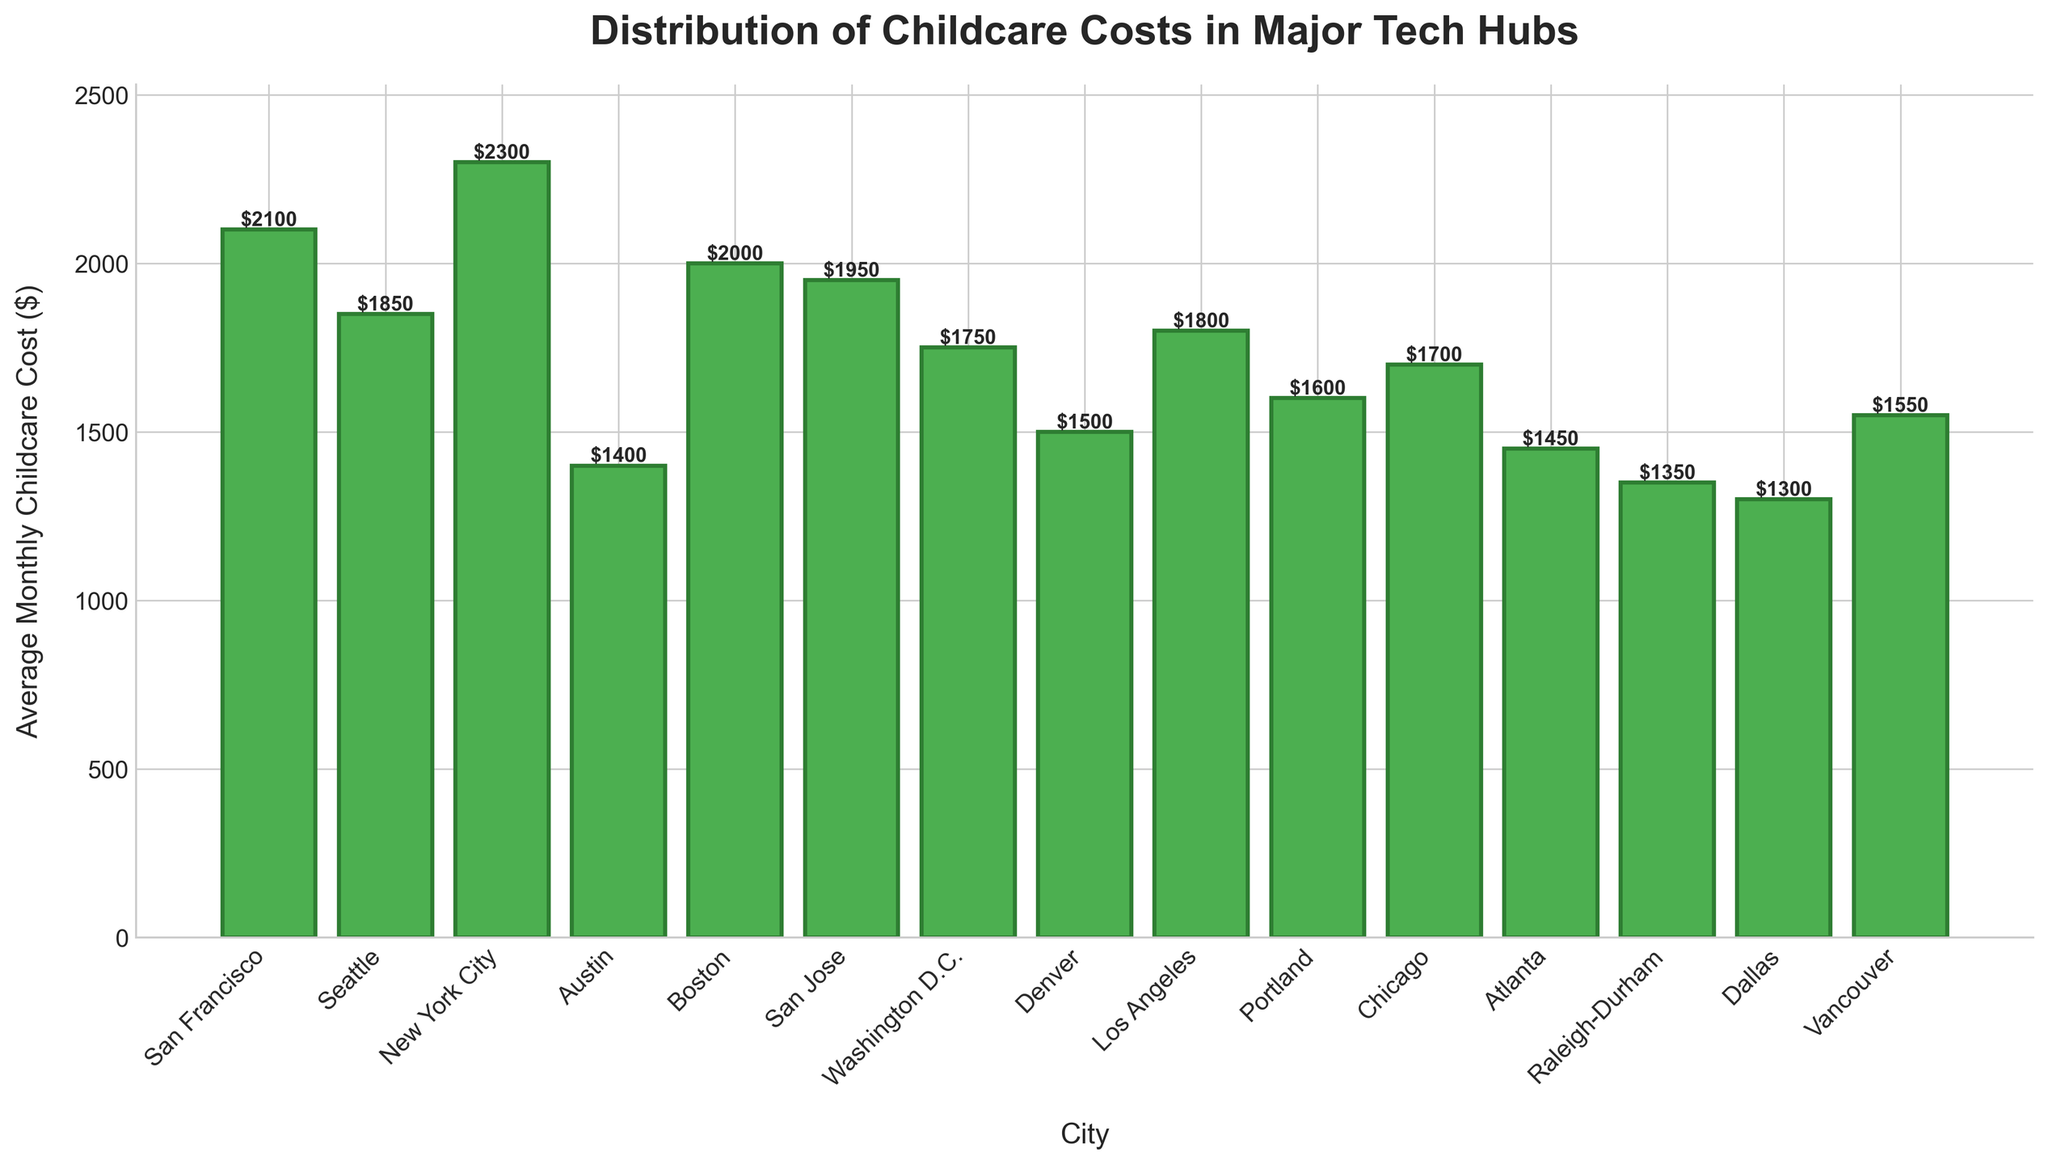Which city has the highest average monthly childcare cost? To find the city with the highest average monthly childcare cost, look at the bar that reaches the highest point on the y-axis. This corresponds to New York City.
Answer: New York City Which city has the lowest average monthly childcare cost? To determine the city with the lowest average monthly childcare cost, find the bar that is the shortest. This corresponds to Dallas.
Answer: Dallas What is the difference in monthly childcare cost between New York City and Austin? New York City's average monthly childcare cost is $2300, and Austin's is $1400. The difference can be calculated as $2300 - $1400.
Answer: $900 What is the combined average monthly childcare cost for San Francisco and Seattle? San Francisco's average monthly childcare cost is $2100, and Seattle's is $1850. The combined cost is $2100 + $1850.
Answer: $3950 Which cities have an average monthly childcare cost less than $1500? Look for the bars that fall below the $1500 mark on the y-axis. These cities are Raleigh-Durham and Dallas.
Answer: Raleigh-Durham, Dallas How much more expensive is average monthly childcare in Boston compared to Atlanta? Boston's average monthly childcare cost is $2000, and Atlanta's is $1450. The difference is $2000 - $1450.
Answer: $550 Is the childcare cost in Los Angeles higher or lower than in Washington D.C.? Check the height of the bars for Los Angeles and Washington D.C. Los Angeles has a cost of $1800, whereas Washington D.C. has a cost of $1750. Since $1800 is higher than $1750, Los Angeles has a higher cost.
Answer: Higher What is the total average monthly childcare cost for all cities combined? Sum all the given average monthly childcare costs: $2100 + $1850 + $2300 + $1400 + $2000 + $1950 + $1750 + $1500 + $1800 + $1600 + $1700 + $1450 + $1350 + $1300 + $1550.
Answer: $29200 Which city has an average monthly childcare cost that is closest to the average of all cities? First, calculate the average of all cities: ($29200 / 15 = $1946.67). Then, find the city with the cost closest to $1946.67. San Jose has a cost of $1950, which is the closest.
Answer: San Jose What is the range of average monthly childcare costs among these cities? To find the range, subtract the lowest cost (Dallas, $1300) from the highest cost (New York City, $2300): $2300 - $1300.
Answer: $1000 